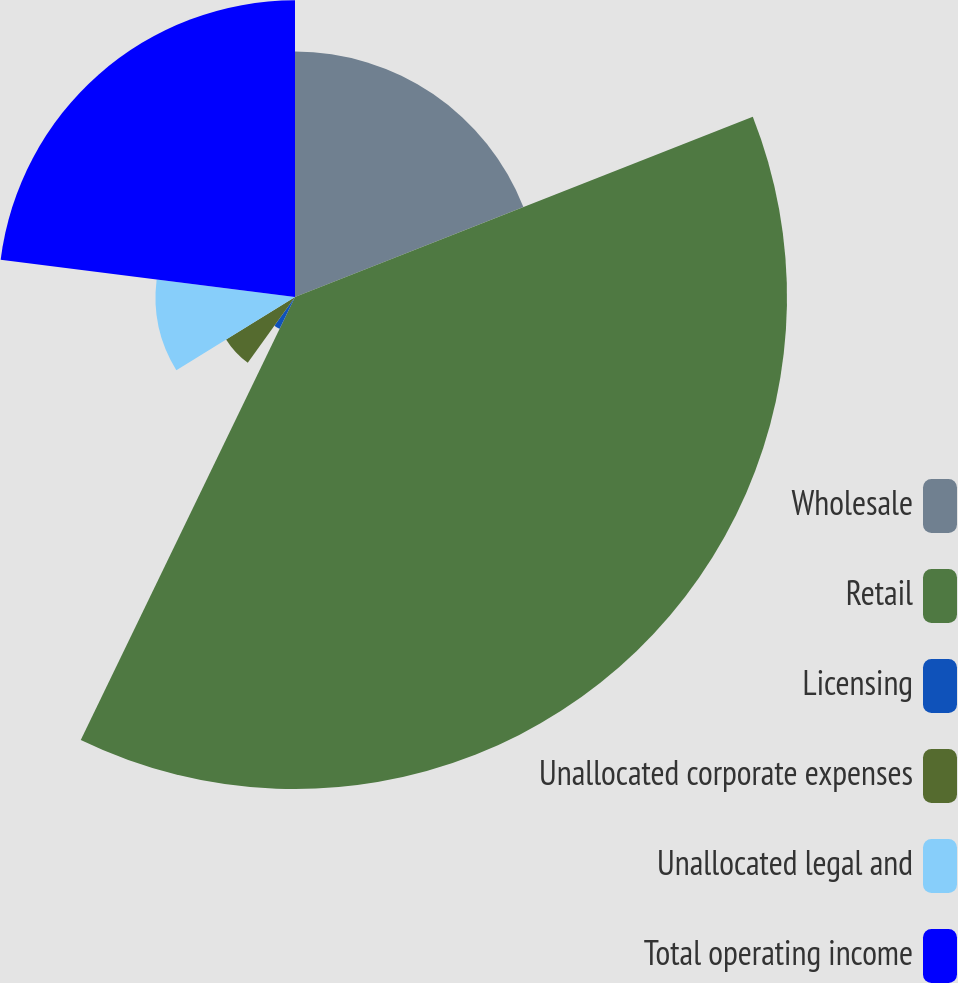Convert chart. <chart><loc_0><loc_0><loc_500><loc_500><pie_chart><fcel>Wholesale<fcel>Retail<fcel>Licensing<fcel>Unallocated corporate expenses<fcel>Unallocated legal and<fcel>Total operating income<nl><fcel>19.03%<fcel>38.14%<fcel>2.74%<fcel>6.28%<fcel>10.81%<fcel>23.0%<nl></chart> 